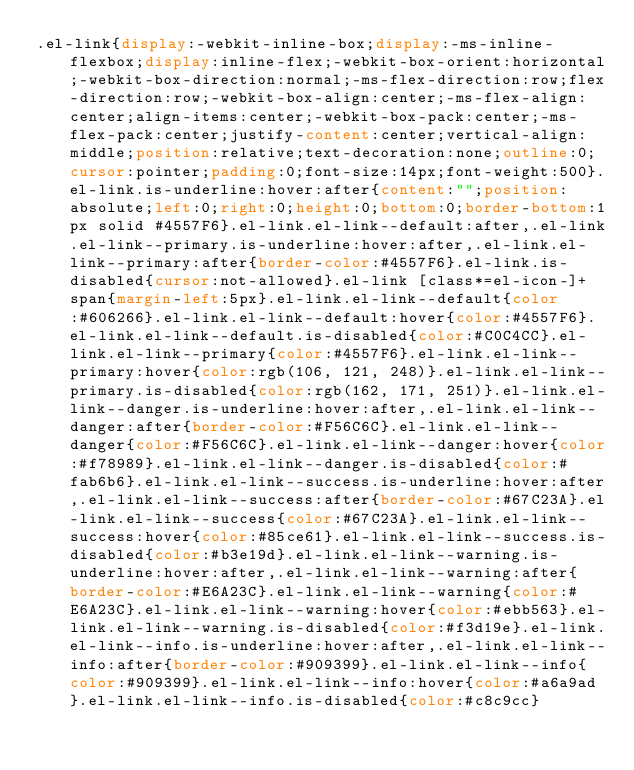<code> <loc_0><loc_0><loc_500><loc_500><_CSS_>.el-link{display:-webkit-inline-box;display:-ms-inline-flexbox;display:inline-flex;-webkit-box-orient:horizontal;-webkit-box-direction:normal;-ms-flex-direction:row;flex-direction:row;-webkit-box-align:center;-ms-flex-align:center;align-items:center;-webkit-box-pack:center;-ms-flex-pack:center;justify-content:center;vertical-align:middle;position:relative;text-decoration:none;outline:0;cursor:pointer;padding:0;font-size:14px;font-weight:500}.el-link.is-underline:hover:after{content:"";position:absolute;left:0;right:0;height:0;bottom:0;border-bottom:1px solid #4557F6}.el-link.el-link--default:after,.el-link.el-link--primary.is-underline:hover:after,.el-link.el-link--primary:after{border-color:#4557F6}.el-link.is-disabled{cursor:not-allowed}.el-link [class*=el-icon-]+span{margin-left:5px}.el-link.el-link--default{color:#606266}.el-link.el-link--default:hover{color:#4557F6}.el-link.el-link--default.is-disabled{color:#C0C4CC}.el-link.el-link--primary{color:#4557F6}.el-link.el-link--primary:hover{color:rgb(106, 121, 248)}.el-link.el-link--primary.is-disabled{color:rgb(162, 171, 251)}.el-link.el-link--danger.is-underline:hover:after,.el-link.el-link--danger:after{border-color:#F56C6C}.el-link.el-link--danger{color:#F56C6C}.el-link.el-link--danger:hover{color:#f78989}.el-link.el-link--danger.is-disabled{color:#fab6b6}.el-link.el-link--success.is-underline:hover:after,.el-link.el-link--success:after{border-color:#67C23A}.el-link.el-link--success{color:#67C23A}.el-link.el-link--success:hover{color:#85ce61}.el-link.el-link--success.is-disabled{color:#b3e19d}.el-link.el-link--warning.is-underline:hover:after,.el-link.el-link--warning:after{border-color:#E6A23C}.el-link.el-link--warning{color:#E6A23C}.el-link.el-link--warning:hover{color:#ebb563}.el-link.el-link--warning.is-disabled{color:#f3d19e}.el-link.el-link--info.is-underline:hover:after,.el-link.el-link--info:after{border-color:#909399}.el-link.el-link--info{color:#909399}.el-link.el-link--info:hover{color:#a6a9ad}.el-link.el-link--info.is-disabled{color:#c8c9cc}</code> 